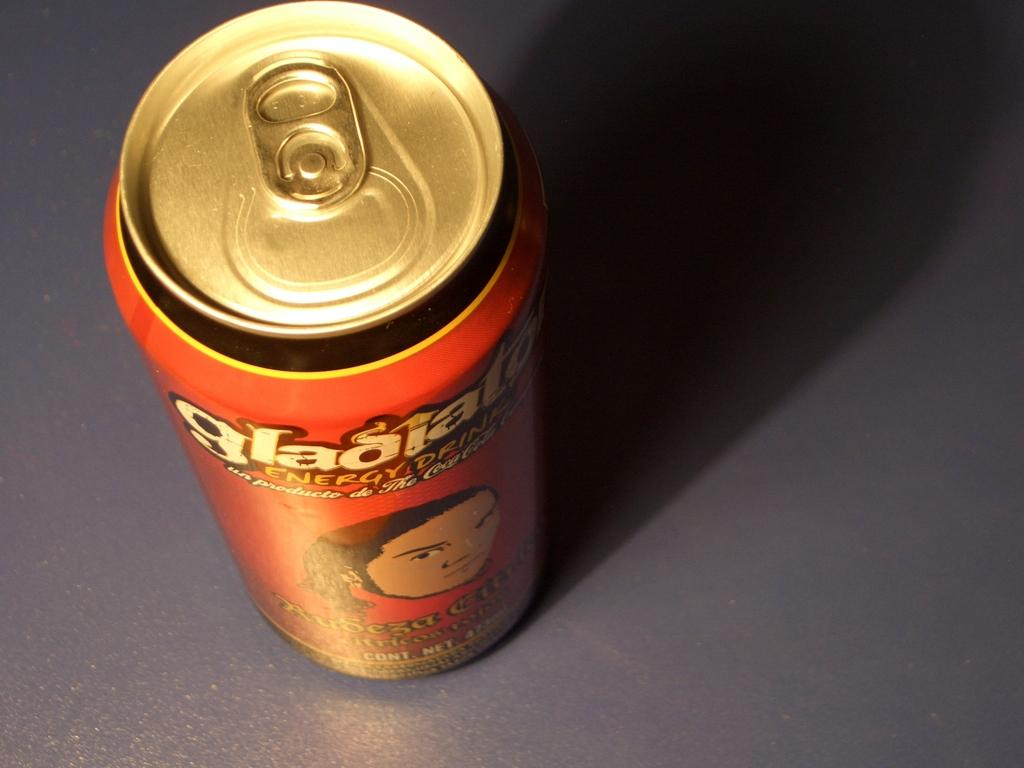<image>
Write a terse but informative summary of the picture. a can of soda that has the word glad on it 